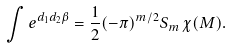<formula> <loc_0><loc_0><loc_500><loc_500>\int e ^ { d _ { 1 } d _ { 2 } \beta } = \frac { 1 } { 2 } ( - \pi ) ^ { m / 2 } S _ { m } \, \chi ( M ) .</formula> 